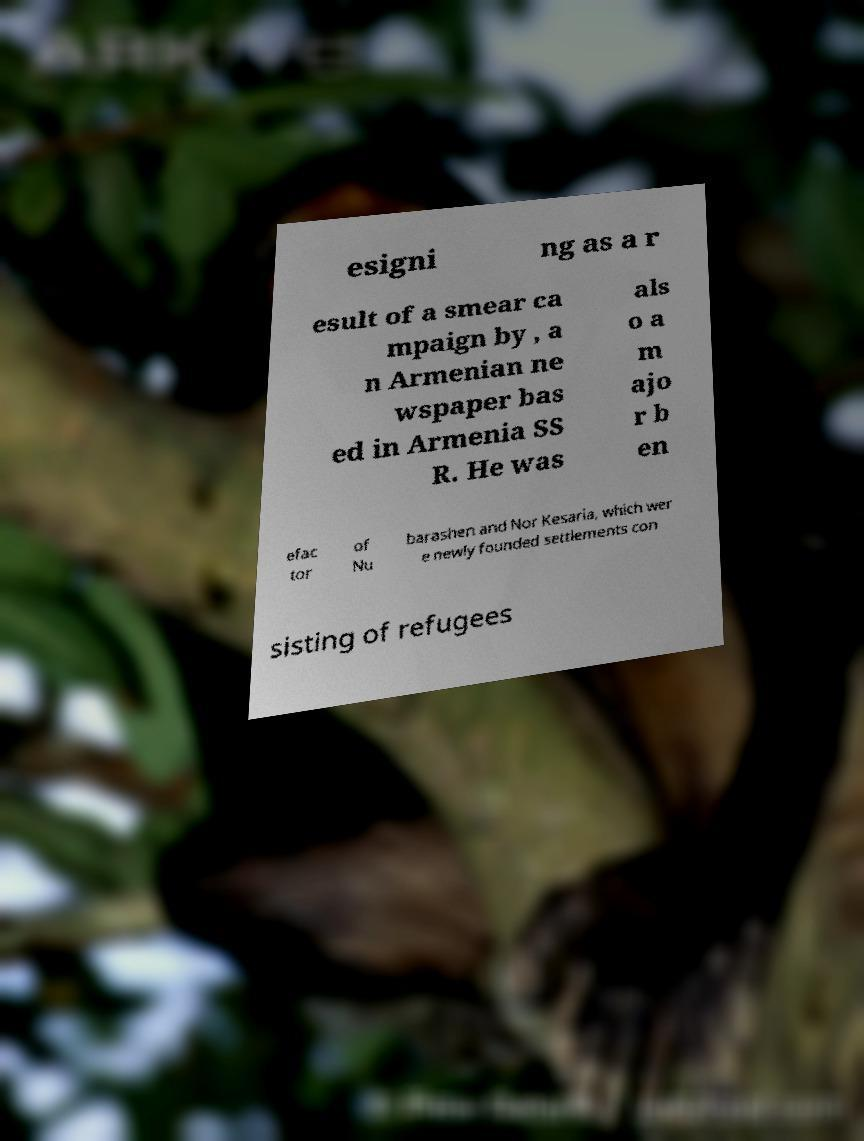There's text embedded in this image that I need extracted. Can you transcribe it verbatim? esigni ng as a r esult of a smear ca mpaign by , a n Armenian ne wspaper bas ed in Armenia SS R. He was als o a m ajo r b en efac tor of Nu barashen and Nor Kesaria, which wer e newly founded settlements con sisting of refugees 